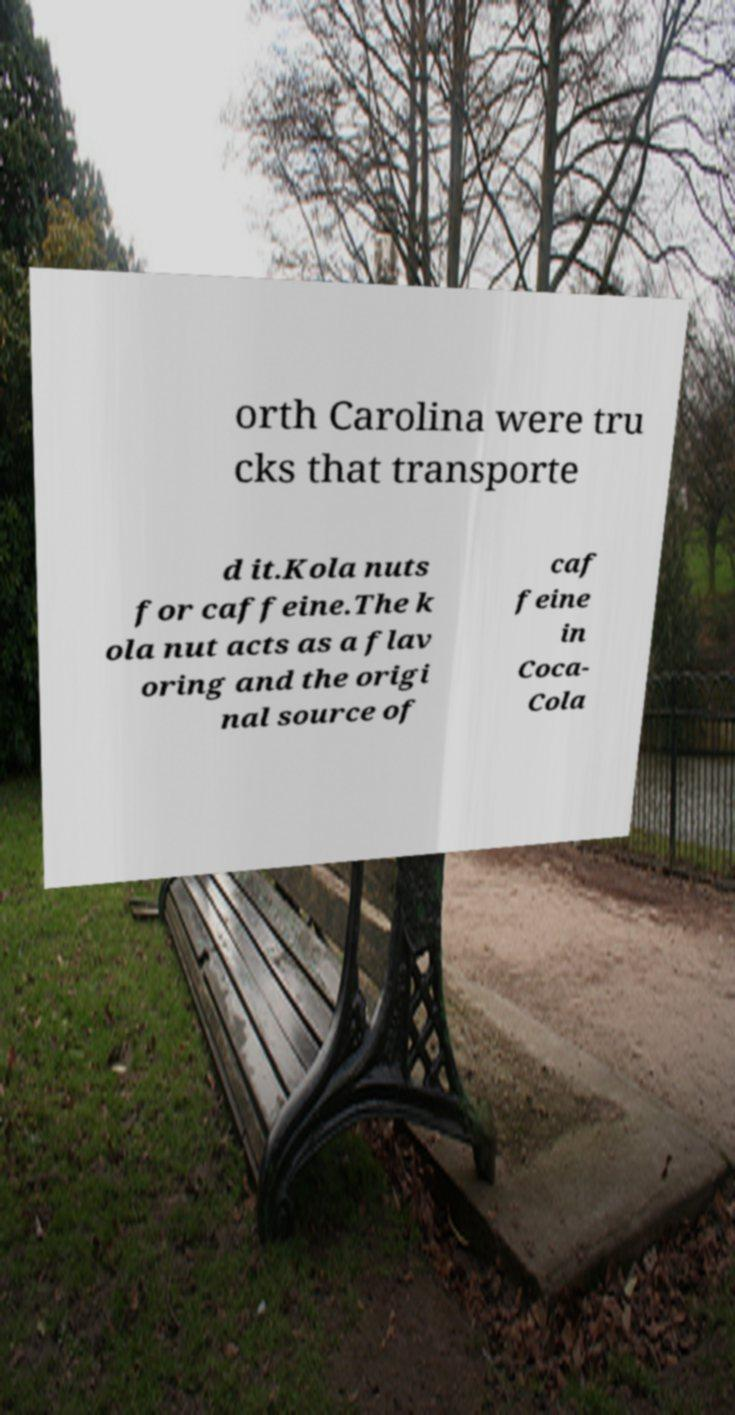Can you accurately transcribe the text from the provided image for me? orth Carolina were tru cks that transporte d it.Kola nuts for caffeine.The k ola nut acts as a flav oring and the origi nal source of caf feine in Coca- Cola 